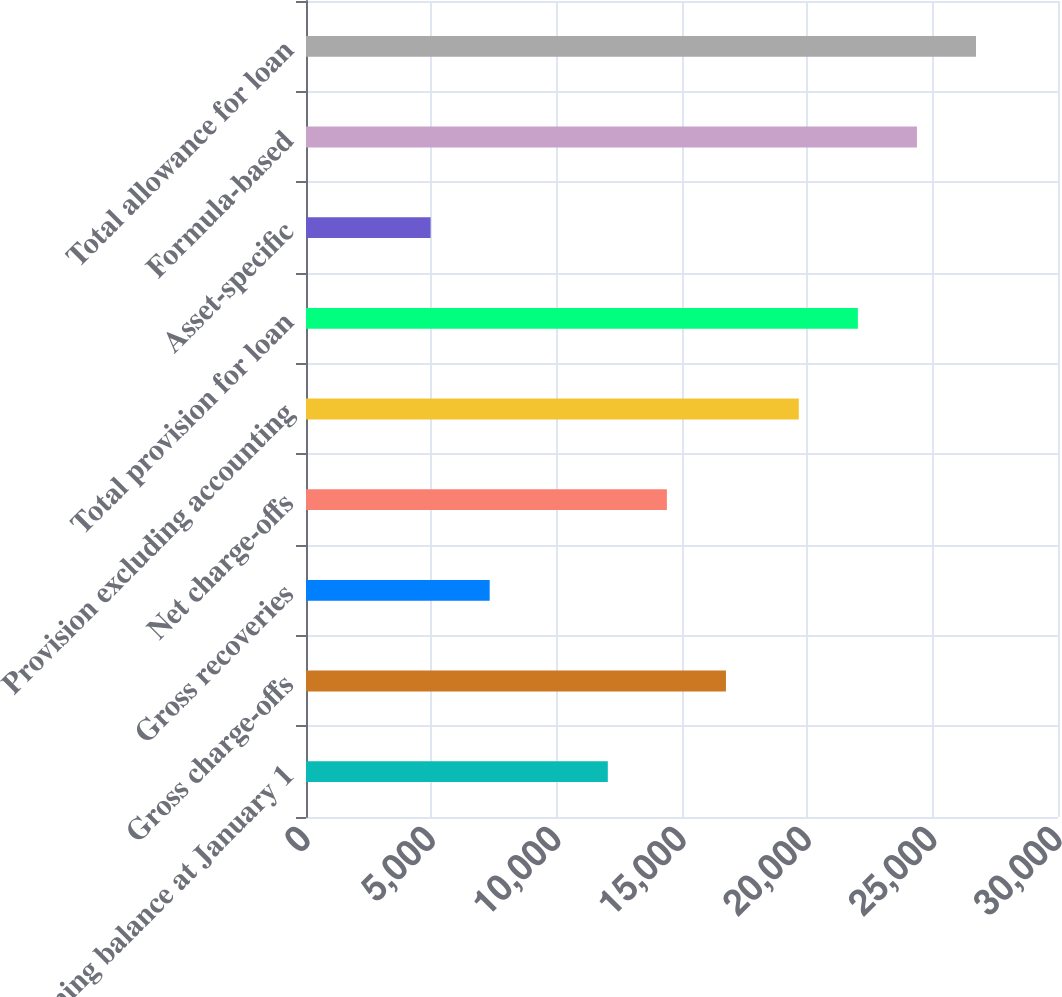<chart> <loc_0><loc_0><loc_500><loc_500><bar_chart><fcel>Beginning balance at January 1<fcel>Gross charge-offs<fcel>Gross recoveries<fcel>Net charge-offs<fcel>Provision excluding accounting<fcel>Total provision for loan<fcel>Asset-specific<fcel>Formula-based<fcel>Total allowance for loan<nl><fcel>12040.5<fcel>16753.5<fcel>7327.5<fcel>14397<fcel>19660<fcel>22016.5<fcel>4971<fcel>24373<fcel>26729.5<nl></chart> 